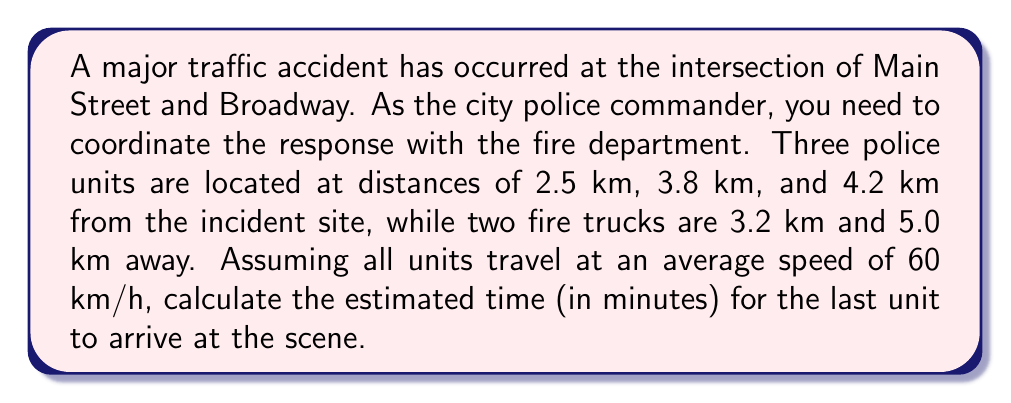Give your solution to this math problem. To solve this problem, we need to follow these steps:

1. Identify the unit that is farthest from the incident site.
2. Calculate the time it takes for this unit to reach the location.

Let's begin:

1. The farthest unit is one of the fire trucks, located 5.0 km away from the incident site.

2. To calculate the time, we use the formula:
   
   $$ \text{Time} = \frac{\text{Distance}}{\text{Speed}} $$

   Here, we need to convert the speed from km/h to km/min:
   
   $$ 60 \text{ km/h} = 1 \text{ km/min} $$

   Now, we can calculate the time:

   $$ \text{Time} = \frac{5.0 \text{ km}}{1 \text{ km/min}} = 5 \text{ minutes} $$

Therefore, the last unit (the fire truck 5.0 km away) will arrive at the scene in 5 minutes.
Answer: 5 minutes 